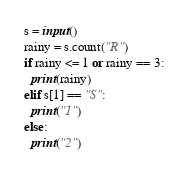<code> <loc_0><loc_0><loc_500><loc_500><_Python_>s = input()
rainy = s.count("R")
if rainy <= 1 or rainy == 3:
  print(rainy)
elif s[1] == "S":
  print("1")
else:
  print("2")</code> 